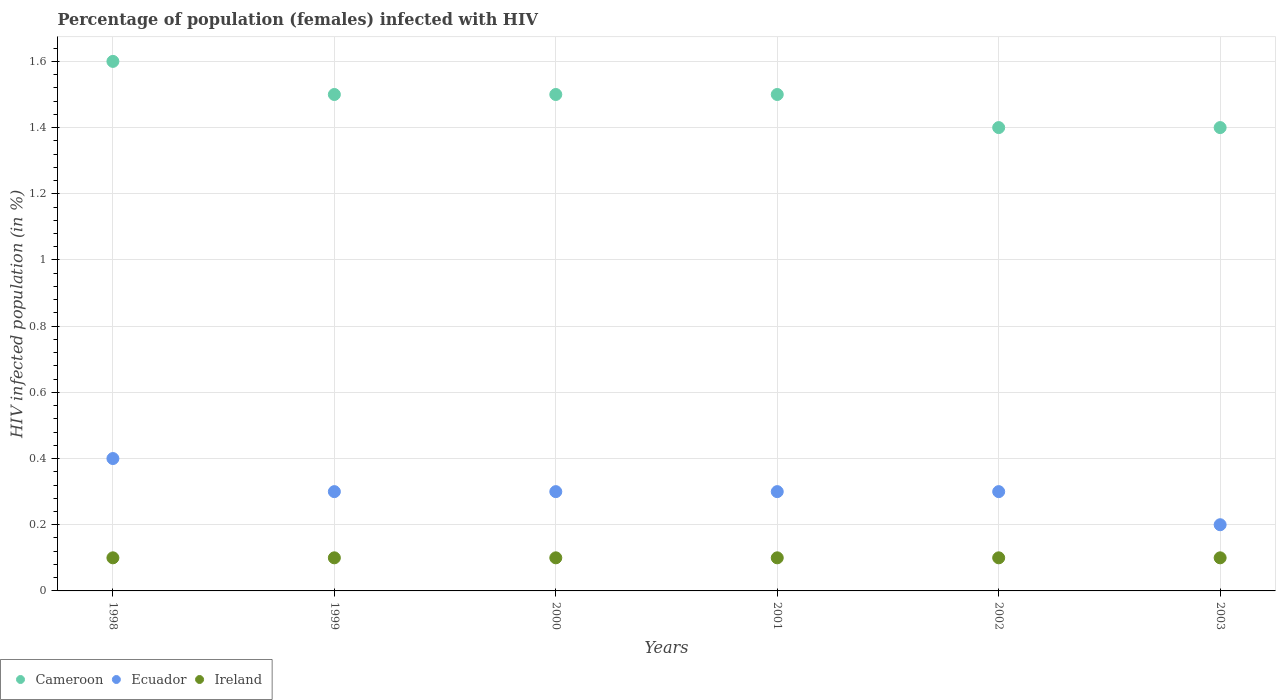What is the percentage of HIV infected female population in Ireland in 2001?
Keep it short and to the point. 0.1. Across all years, what is the minimum percentage of HIV infected female population in Ireland?
Your answer should be very brief. 0.1. In which year was the percentage of HIV infected female population in Ecuador maximum?
Provide a short and direct response. 1998. What is the difference between the percentage of HIV infected female population in Cameroon in 2000 and that in 2001?
Provide a succinct answer. 0. What is the difference between the percentage of HIV infected female population in Ecuador in 2003 and the percentage of HIV infected female population in Ireland in 2000?
Offer a terse response. 0.1. What is the average percentage of HIV infected female population in Ecuador per year?
Make the answer very short. 0.3. In the year 1999, what is the difference between the percentage of HIV infected female population in Ecuador and percentage of HIV infected female population in Ireland?
Offer a very short reply. 0.2. In how many years, is the percentage of HIV infected female population in Ireland greater than 1.4400000000000002 %?
Offer a very short reply. 0. What is the ratio of the percentage of HIV infected female population in Ecuador in 2000 to that in 2003?
Offer a terse response. 1.5. Is the difference between the percentage of HIV infected female population in Ecuador in 1998 and 2000 greater than the difference between the percentage of HIV infected female population in Ireland in 1998 and 2000?
Give a very brief answer. Yes. What is the difference between the highest and the lowest percentage of HIV infected female population in Cameroon?
Offer a terse response. 0.2. In how many years, is the percentage of HIV infected female population in Ecuador greater than the average percentage of HIV infected female population in Ecuador taken over all years?
Your answer should be compact. 1. Is the percentage of HIV infected female population in Ecuador strictly greater than the percentage of HIV infected female population in Cameroon over the years?
Offer a very short reply. No. What is the difference between two consecutive major ticks on the Y-axis?
Your answer should be compact. 0.2. Are the values on the major ticks of Y-axis written in scientific E-notation?
Make the answer very short. No. Does the graph contain any zero values?
Ensure brevity in your answer.  No. Does the graph contain grids?
Offer a terse response. Yes. What is the title of the graph?
Provide a short and direct response. Percentage of population (females) infected with HIV. Does "Lithuania" appear as one of the legend labels in the graph?
Ensure brevity in your answer.  No. What is the label or title of the X-axis?
Your response must be concise. Years. What is the label or title of the Y-axis?
Offer a terse response. HIV infected population (in %). What is the HIV infected population (in %) in Cameroon in 1998?
Offer a terse response. 1.6. What is the HIV infected population (in %) in Cameroon in 1999?
Give a very brief answer. 1.5. What is the HIV infected population (in %) of Ireland in 1999?
Provide a succinct answer. 0.1. What is the HIV infected population (in %) in Ireland in 2000?
Provide a succinct answer. 0.1. What is the HIV infected population (in %) in Ecuador in 2001?
Your answer should be very brief. 0.3. What is the HIV infected population (in %) in Cameroon in 2002?
Offer a terse response. 1.4. What is the HIV infected population (in %) in Ecuador in 2002?
Your answer should be very brief. 0.3. What is the HIV infected population (in %) of Cameroon in 2003?
Your answer should be very brief. 1.4. What is the HIV infected population (in %) of Ireland in 2003?
Offer a terse response. 0.1. Across all years, what is the maximum HIV infected population (in %) of Ecuador?
Give a very brief answer. 0.4. Across all years, what is the minimum HIV infected population (in %) of Cameroon?
Ensure brevity in your answer.  1.4. Across all years, what is the minimum HIV infected population (in %) of Ecuador?
Offer a terse response. 0.2. What is the difference between the HIV infected population (in %) of Cameroon in 1998 and that in 2000?
Your answer should be compact. 0.1. What is the difference between the HIV infected population (in %) in Cameroon in 1998 and that in 2001?
Make the answer very short. 0.1. What is the difference between the HIV infected population (in %) of Ecuador in 1998 and that in 2001?
Your answer should be very brief. 0.1. What is the difference between the HIV infected population (in %) of Ireland in 1998 and that in 2002?
Offer a terse response. 0. What is the difference between the HIV infected population (in %) in Ecuador in 1998 and that in 2003?
Ensure brevity in your answer.  0.2. What is the difference between the HIV infected population (in %) in Ireland in 1998 and that in 2003?
Keep it short and to the point. 0. What is the difference between the HIV infected population (in %) of Ireland in 1999 and that in 2000?
Provide a succinct answer. 0. What is the difference between the HIV infected population (in %) in Cameroon in 1999 and that in 2001?
Make the answer very short. 0. What is the difference between the HIV infected population (in %) of Ireland in 1999 and that in 2001?
Keep it short and to the point. 0. What is the difference between the HIV infected population (in %) of Cameroon in 1999 and that in 2002?
Provide a succinct answer. 0.1. What is the difference between the HIV infected population (in %) in Ecuador in 1999 and that in 2002?
Offer a very short reply. 0. What is the difference between the HIV infected population (in %) of Ireland in 1999 and that in 2002?
Provide a short and direct response. 0. What is the difference between the HIV infected population (in %) in Cameroon in 1999 and that in 2003?
Provide a short and direct response. 0.1. What is the difference between the HIV infected population (in %) in Ecuador in 1999 and that in 2003?
Your response must be concise. 0.1. What is the difference between the HIV infected population (in %) in Ecuador in 2000 and that in 2002?
Offer a very short reply. 0. What is the difference between the HIV infected population (in %) of Ireland in 2000 and that in 2002?
Offer a terse response. 0. What is the difference between the HIV infected population (in %) of Cameroon in 2001 and that in 2002?
Your answer should be very brief. 0.1. What is the difference between the HIV infected population (in %) of Ecuador in 2001 and that in 2002?
Offer a terse response. 0. What is the difference between the HIV infected population (in %) in Cameroon in 2001 and that in 2003?
Make the answer very short. 0.1. What is the difference between the HIV infected population (in %) in Ireland in 2001 and that in 2003?
Your response must be concise. 0. What is the difference between the HIV infected population (in %) in Ecuador in 2002 and that in 2003?
Offer a terse response. 0.1. What is the difference between the HIV infected population (in %) in Cameroon in 1998 and the HIV infected population (in %) in Ireland in 1999?
Offer a terse response. 1.5. What is the difference between the HIV infected population (in %) in Cameroon in 1998 and the HIV infected population (in %) in Ireland in 2000?
Keep it short and to the point. 1.5. What is the difference between the HIV infected population (in %) in Cameroon in 1998 and the HIV infected population (in %) in Ecuador in 2002?
Provide a succinct answer. 1.3. What is the difference between the HIV infected population (in %) of Cameroon in 1998 and the HIV infected population (in %) of Ireland in 2002?
Offer a terse response. 1.5. What is the difference between the HIV infected population (in %) in Cameroon in 1998 and the HIV infected population (in %) in Ecuador in 2003?
Your answer should be very brief. 1.4. What is the difference between the HIV infected population (in %) of Cameroon in 1999 and the HIV infected population (in %) of Ecuador in 2000?
Offer a very short reply. 1.2. What is the difference between the HIV infected population (in %) in Cameroon in 1999 and the HIV infected population (in %) in Ireland in 2000?
Your answer should be compact. 1.4. What is the difference between the HIV infected population (in %) in Cameroon in 1999 and the HIV infected population (in %) in Ireland in 2002?
Your answer should be very brief. 1.4. What is the difference between the HIV infected population (in %) of Ecuador in 1999 and the HIV infected population (in %) of Ireland in 2002?
Your response must be concise. 0.2. What is the difference between the HIV infected population (in %) of Cameroon in 1999 and the HIV infected population (in %) of Ireland in 2003?
Keep it short and to the point. 1.4. What is the difference between the HIV infected population (in %) of Cameroon in 2000 and the HIV infected population (in %) of Ecuador in 2001?
Provide a short and direct response. 1.2. What is the difference between the HIV infected population (in %) in Cameroon in 2000 and the HIV infected population (in %) in Ireland in 2001?
Offer a terse response. 1.4. What is the difference between the HIV infected population (in %) of Cameroon in 2000 and the HIV infected population (in %) of Ecuador in 2002?
Provide a short and direct response. 1.2. What is the difference between the HIV infected population (in %) in Cameroon in 2000 and the HIV infected population (in %) in Ireland in 2002?
Offer a very short reply. 1.4. What is the difference between the HIV infected population (in %) in Cameroon in 2000 and the HIV infected population (in %) in Ecuador in 2003?
Your response must be concise. 1.3. What is the difference between the HIV infected population (in %) of Ecuador in 2000 and the HIV infected population (in %) of Ireland in 2003?
Keep it short and to the point. 0.2. What is the difference between the HIV infected population (in %) in Cameroon in 2001 and the HIV infected population (in %) in Ecuador in 2002?
Keep it short and to the point. 1.2. What is the difference between the HIV infected population (in %) in Cameroon in 2001 and the HIV infected population (in %) in Ireland in 2002?
Ensure brevity in your answer.  1.4. What is the difference between the HIV infected population (in %) of Ecuador in 2001 and the HIV infected population (in %) of Ireland in 2003?
Give a very brief answer. 0.2. What is the average HIV infected population (in %) of Cameroon per year?
Ensure brevity in your answer.  1.48. What is the average HIV infected population (in %) of Ecuador per year?
Make the answer very short. 0.3. In the year 1998, what is the difference between the HIV infected population (in %) of Cameroon and HIV infected population (in %) of Ireland?
Make the answer very short. 1.5. In the year 1999, what is the difference between the HIV infected population (in %) in Cameroon and HIV infected population (in %) in Ecuador?
Keep it short and to the point. 1.2. In the year 1999, what is the difference between the HIV infected population (in %) in Cameroon and HIV infected population (in %) in Ireland?
Offer a terse response. 1.4. In the year 1999, what is the difference between the HIV infected population (in %) of Ecuador and HIV infected population (in %) of Ireland?
Offer a very short reply. 0.2. In the year 2000, what is the difference between the HIV infected population (in %) of Cameroon and HIV infected population (in %) of Ecuador?
Your answer should be compact. 1.2. In the year 2001, what is the difference between the HIV infected population (in %) of Cameroon and HIV infected population (in %) of Ecuador?
Offer a terse response. 1.2. In the year 2002, what is the difference between the HIV infected population (in %) in Ecuador and HIV infected population (in %) in Ireland?
Provide a succinct answer. 0.2. In the year 2003, what is the difference between the HIV infected population (in %) in Cameroon and HIV infected population (in %) in Ecuador?
Offer a terse response. 1.2. In the year 2003, what is the difference between the HIV infected population (in %) of Ecuador and HIV infected population (in %) of Ireland?
Keep it short and to the point. 0.1. What is the ratio of the HIV infected population (in %) of Cameroon in 1998 to that in 1999?
Offer a terse response. 1.07. What is the ratio of the HIV infected population (in %) of Ecuador in 1998 to that in 1999?
Offer a very short reply. 1.33. What is the ratio of the HIV infected population (in %) of Cameroon in 1998 to that in 2000?
Provide a short and direct response. 1.07. What is the ratio of the HIV infected population (in %) of Cameroon in 1998 to that in 2001?
Make the answer very short. 1.07. What is the ratio of the HIV infected population (in %) of Ecuador in 1998 to that in 2001?
Offer a terse response. 1.33. What is the ratio of the HIV infected population (in %) of Ireland in 1998 to that in 2001?
Your answer should be very brief. 1. What is the ratio of the HIV infected population (in %) in Ecuador in 1998 to that in 2002?
Your answer should be very brief. 1.33. What is the ratio of the HIV infected population (in %) of Ireland in 1998 to that in 2002?
Offer a terse response. 1. What is the ratio of the HIV infected population (in %) of Ireland in 1998 to that in 2003?
Your answer should be very brief. 1. What is the ratio of the HIV infected population (in %) of Ecuador in 1999 to that in 2001?
Provide a succinct answer. 1. What is the ratio of the HIV infected population (in %) of Cameroon in 1999 to that in 2002?
Your response must be concise. 1.07. What is the ratio of the HIV infected population (in %) of Ecuador in 1999 to that in 2002?
Make the answer very short. 1. What is the ratio of the HIV infected population (in %) in Ireland in 1999 to that in 2002?
Offer a terse response. 1. What is the ratio of the HIV infected population (in %) in Cameroon in 1999 to that in 2003?
Keep it short and to the point. 1.07. What is the ratio of the HIV infected population (in %) of Ireland in 1999 to that in 2003?
Your answer should be very brief. 1. What is the ratio of the HIV infected population (in %) of Cameroon in 2000 to that in 2002?
Your answer should be compact. 1.07. What is the ratio of the HIV infected population (in %) of Ecuador in 2000 to that in 2002?
Ensure brevity in your answer.  1. What is the ratio of the HIV infected population (in %) of Cameroon in 2000 to that in 2003?
Your response must be concise. 1.07. What is the ratio of the HIV infected population (in %) in Ireland in 2000 to that in 2003?
Your response must be concise. 1. What is the ratio of the HIV infected population (in %) of Cameroon in 2001 to that in 2002?
Ensure brevity in your answer.  1.07. What is the ratio of the HIV infected population (in %) in Ireland in 2001 to that in 2002?
Provide a short and direct response. 1. What is the ratio of the HIV infected population (in %) of Cameroon in 2001 to that in 2003?
Ensure brevity in your answer.  1.07. What is the ratio of the HIV infected population (in %) in Ireland in 2002 to that in 2003?
Your answer should be compact. 1. What is the difference between the highest and the second highest HIV infected population (in %) in Ecuador?
Offer a very short reply. 0.1. What is the difference between the highest and the second highest HIV infected population (in %) in Ireland?
Your answer should be very brief. 0. What is the difference between the highest and the lowest HIV infected population (in %) of Ecuador?
Give a very brief answer. 0.2. 